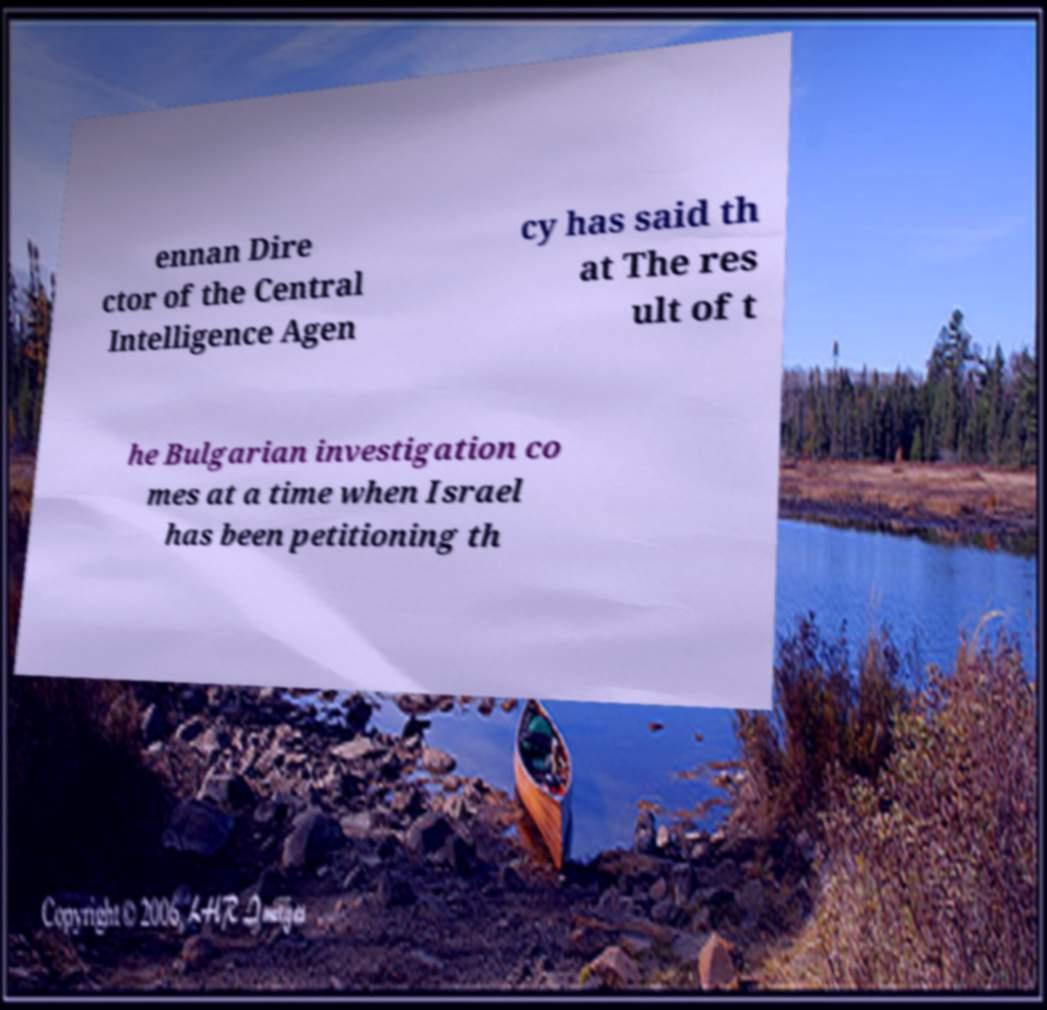Could you extract and type out the text from this image? ennan Dire ctor of the Central Intelligence Agen cy has said th at The res ult of t he Bulgarian investigation co mes at a time when Israel has been petitioning th 